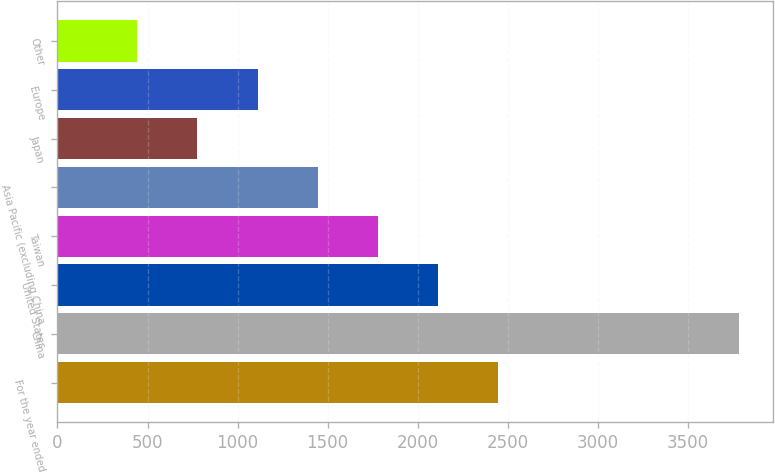Convert chart to OTSL. <chart><loc_0><loc_0><loc_500><loc_500><bar_chart><fcel>For the year ended<fcel>China<fcel>United States<fcel>Taiwan<fcel>Asia Pacific (excluding China<fcel>Japan<fcel>Europe<fcel>Other<nl><fcel>2447<fcel>3783<fcel>2113<fcel>1779<fcel>1445<fcel>777<fcel>1111<fcel>443<nl></chart> 